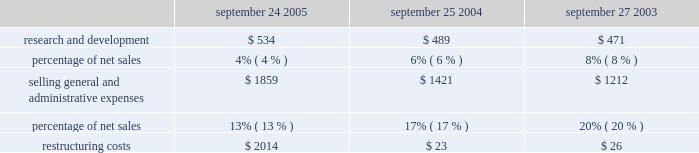The company orders components for its products and builds inventory in advance of product shipments .
Because the company 2019s markets are volatile and subject to rapid technology and price changes , there is a risk the company will forecast incorrectly and produce or order from third-parties excess or insufficient inventories of particular products or components .
The company 2019s operating results and financial condition in the past have been and may in the future be materially adversely affected by the company 2019s ability to manage its inventory levels and outstanding purchase commitments and to respond to short-term shifts in customer demand patterns .
Gross margin declined in 2004 to 27.3% ( 27.3 % ) of net sales from 27.5% ( 27.5 % ) of net sales in 2003 .
The company 2019s gross margin during 2004 declined due to an increase in mix towards lower margin ipod and ibook sales , pricing actions on certain power macintosh g5 models that were transitioned during the beginning of 2004 , higher warranty costs on certain portable macintosh products , and higher freight and duty costs during 2004 .
These unfavorable factors were partially offset by an increase in direct sales and a 39% ( 39 % ) year-over-year increase in higher margin software sales .
Operating expenses operating expenses for each of the last three fiscal years are as follows ( in millions , except for percentages ) : september 24 , september 25 , september 27 , 2005 2004 2003 .
Research and development ( r&d ) the company recognizes that focused investments in r&d are critical to its future growth and competitive position in the marketplace and are directly related to timely development of new and enhanced products that are central to the company 2019s core business strategy .
The company has historically relied upon innovation to remain competitive .
R&d expense amounted to approximately 4% ( 4 % ) of total net sales during 2005 down from 6% ( 6 % ) and 8% ( 8 % ) of total net sales in 2004 and 2003 , respectively .
This decrease is due to the significant increase of 68% ( 68 % ) in total net sales of the company for 2005 .
Although r&d expense decreased as a percentage of total net sales in 2005 , actual expense for r&d in 2005 increased $ 45 million or 9% ( 9 % ) from 2004 , which follows an $ 18 million or 4% ( 4 % ) increase in 2004 compared to 2003 .
The overall increase in r&d expense relates primarily to increased headcount and support for new product development activities and the impact of employee salary increases in 2005 .
R&d expense does not include capitalized software development costs of approximately $ 29.7 million related to the development of mac os x tiger during 2005 ; $ 4.5 million related to the development of mac os x tiger and $ 2.3 million related to the development of filemaker pro 7 in 2004 ; and $ 14.7 million related to the development of mac os x panther in 2003 .
Further information related to the company 2019s capitalization of software development costs may be found in part ii , item 8 of this form 10-k at note 1 of notes to consolidated financial statements .
Selling , general , and administrative expense ( sg&a ) expenditures for sg&a increased $ 438 million or 31% ( 31 % ) during 2005 compared to 2004 .
These increases are due primarily to the company 2019s continued expansion of its retail segment in both domestic and international markets , a current year increase in discretionary spending on marketing and advertising , and higher direct and channel selling expenses resulting from the increase in net sales and employee salary .
What was the average research and development expense for fye 2003-2005 , in millions ? $ 534 $ 489 $ 471? 
Computations: table_average(research and development, none)
Answer: 498.0. 